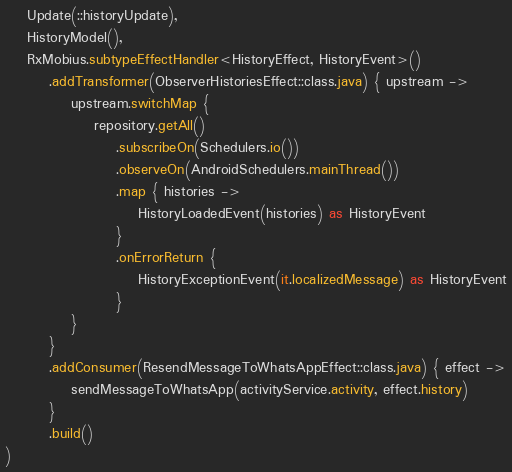Convert code to text. <code><loc_0><loc_0><loc_500><loc_500><_Kotlin_>    Update(::historyUpdate),
    HistoryModel(),
    RxMobius.subtypeEffectHandler<HistoryEffect, HistoryEvent>()
        .addTransformer(ObserverHistoriesEffect::class.java) { upstream ->
            upstream.switchMap {
                repository.getAll()
                    .subscribeOn(Schedulers.io())
                    .observeOn(AndroidSchedulers.mainThread())
                    .map { histories ->
                        HistoryLoadedEvent(histories) as HistoryEvent
                    }
                    .onErrorReturn {
                        HistoryExceptionEvent(it.localizedMessage) as HistoryEvent
                    }
            }
        }
        .addConsumer(ResendMessageToWhatsAppEffect::class.java) { effect ->
            sendMessageToWhatsApp(activityService.activity, effect.history)
        }
        .build()
)
</code> 